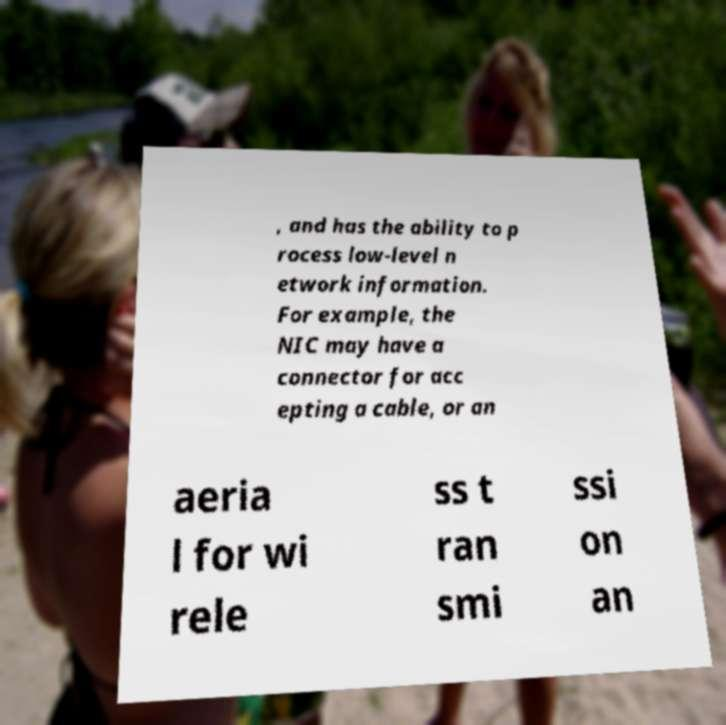Can you accurately transcribe the text from the provided image for me? , and has the ability to p rocess low-level n etwork information. For example, the NIC may have a connector for acc epting a cable, or an aeria l for wi rele ss t ran smi ssi on an 